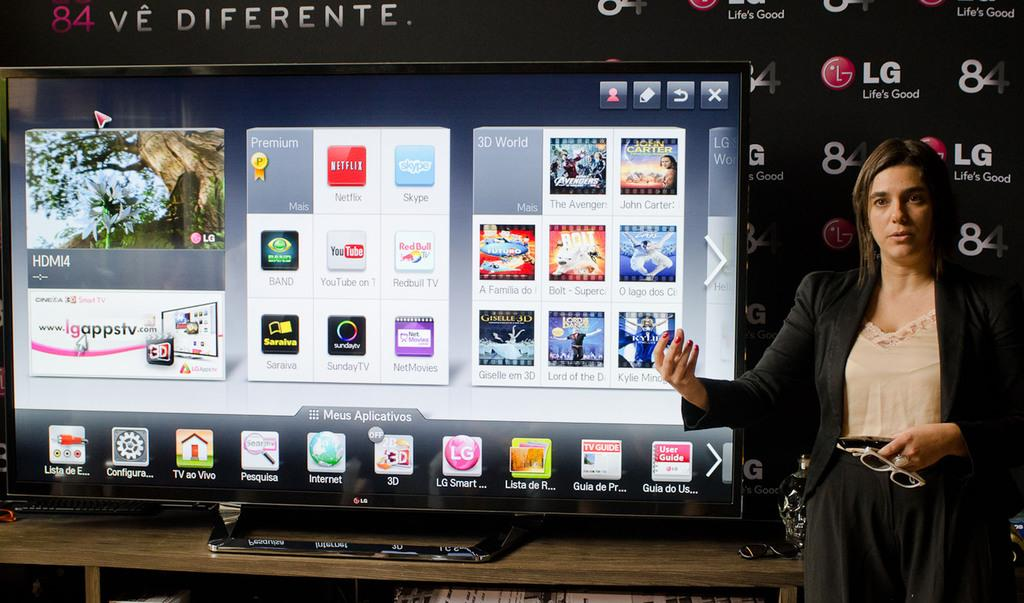<image>
Write a terse but informative summary of the picture. A woman stands in front of a large LG television. 